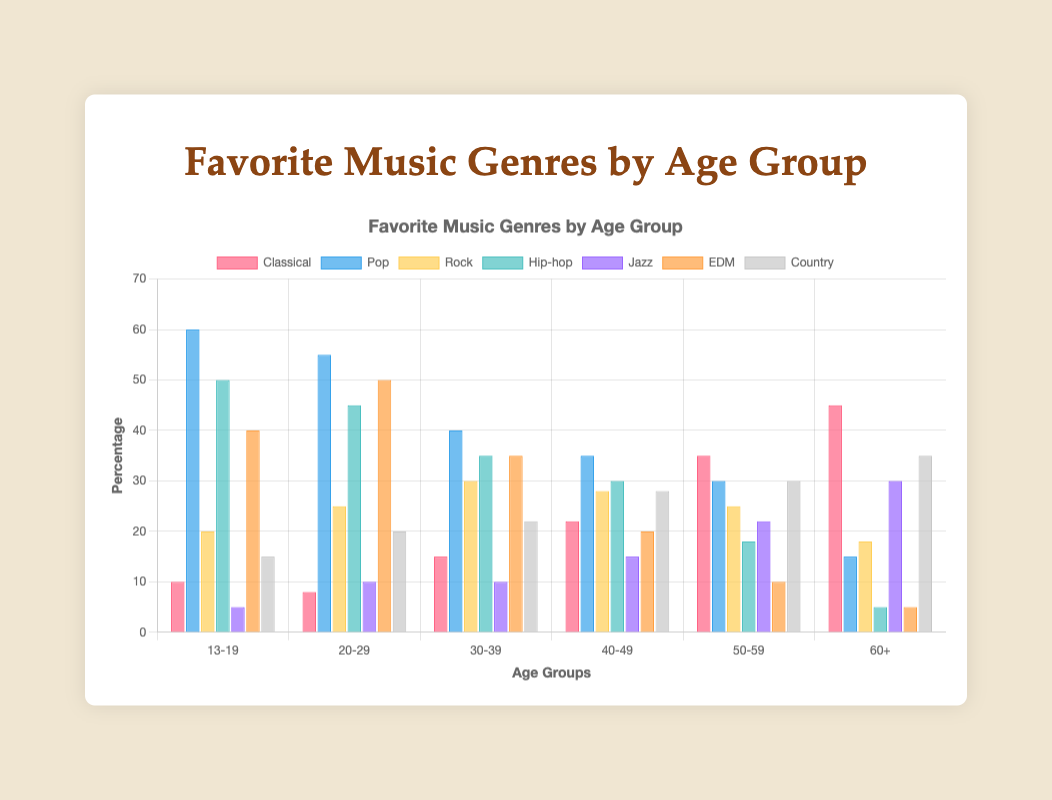What's the most popular music genre among the 13-19 age group? Observing the height of the bars for the 13-19 age group, the Pop genre has the tallest bar, indicating it is the most popular.
Answer: Pop Which age group shows the highest preference for Classical music? By comparing the heights of the bars for the Classical genre across all age groups, the 60+ age group has the tallest bar.
Answer: 60+ How does the preference for Hip-hop change from the 13-19 age group to the 60+ age group? The bar height for Hip-hop in the 13-19 age group is 50, and it decreases progressively to 5 in the 60+ age group. The preference drops significantly.
Answer: Decreases Between the 30-39 and 40-49 age groups, which prefers Jazz more? By comparing the heights of the Jazz bars, the 40-49 age group has a taller bar than the 30-39 age group.
Answer: 40-49 Calculate the total preference percentage for Classical music across all age groups. Summing the percentages: 10 + 8 + 15 + 22 + 35 + 45 = 135
Answer: 135 Is EDM more popular than Jazz among the 20-29 age group? Comparing the height of the EDM bar (50) to the Jazz bar (10) for the 20-29 age group, EDM is more popular.
Answer: Yes Which genre has the smallest difference in preference between the oldest and youngest age groups? Calculating differences: Classical (45-10=35), Pop (60-15=45), Rock (18-20=-2), Hip-hop (50-5=45), Jazz (30-5=25), EDM (40-5=35), Country (35-15=20). Rock has the smallest difference (-2).
Answer: Rock What is the average preference for Pop music across all age groups? Summing the preferences and dividing by 6: (60 + 55 + 40 + 35 + 30 + 15)/6 = 235/6 ≈ 39.17
Answer: 39.17 How does the preference for Country music change from the 20-29 age group to the 50-59 age group? Comparing the heights: from 20 in the 20-29 age group to 30 in the 50-59 age group, showing an increase.
Answer: Increases 